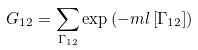Convert formula to latex. <formula><loc_0><loc_0><loc_500><loc_500>G _ { 1 2 } = \sum _ { \Gamma _ { 1 2 } } \exp \left ( - m l \left [ \Gamma _ { 1 2 } \right ] \right )</formula> 